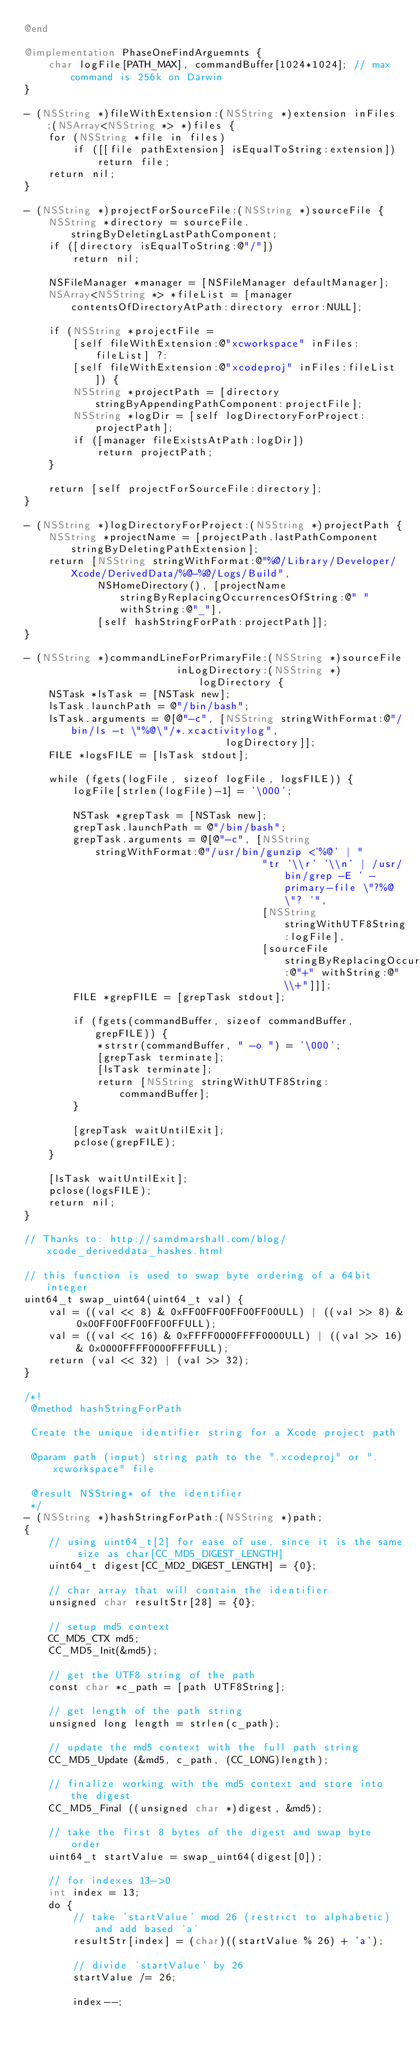Convert code to text. <code><loc_0><loc_0><loc_500><loc_500><_ObjectiveC_>@end

@implementation PhaseOneFindArguemnts {
    char logFile[PATH_MAX], commandBuffer[1024*1024]; // max command is 256k on Darwin
}

- (NSString *)fileWithExtension:(NSString *)extension inFiles:(NSArray<NSString *> *)files {
    for (NSString *file in files)
        if ([[file pathExtension] isEqualToString:extension])
            return file;
    return nil;
}

- (NSString *)projectForSourceFile:(NSString *)sourceFile {
    NSString *directory = sourceFile.stringByDeletingLastPathComponent;
    if ([directory isEqualToString:@"/"])
        return nil;

    NSFileManager *manager = [NSFileManager defaultManager];
    NSArray<NSString *> *fileList = [manager contentsOfDirectoryAtPath:directory error:NULL];

    if (NSString *projectFile =
        [self fileWithExtension:@"xcworkspace" inFiles:fileList] ?:
        [self fileWithExtension:@"xcodeproj" inFiles:fileList]) {
        NSString *projectPath = [directory stringByAppendingPathComponent:projectFile];
        NSString *logDir = [self logDirectoryForProject:projectPath];
        if ([manager fileExistsAtPath:logDir])
            return projectPath;
    }

    return [self projectForSourceFile:directory];
}

- (NSString *)logDirectoryForProject:(NSString *)projectPath {
    NSString *projectName = [projectPath.lastPathComponent stringByDeletingPathExtension];
    return [NSString stringWithFormat:@"%@/Library/Developer/Xcode/DerivedData/%@-%@/Logs/Build",
            NSHomeDirectory(), [projectName stringByReplacingOccurrencesOfString:@" " withString:@"_"],
            [self hashStringForPath:projectPath]];
}

- (NSString *)commandLineForPrimaryFile:(NSString *)sourceFile
                         inLogDirectory:(NSString *)logDirectory {
    NSTask *lsTask = [NSTask new];
    lsTask.launchPath = @"/bin/bash";
    lsTask.arguments = @[@"-c", [NSString stringWithFormat:@"/bin/ls -t \"%@\"/*.xcactivitylog",
                                 logDirectory]];
    FILE *logsFILE = [lsTask stdout];

    while (fgets(logFile, sizeof logFile, logsFILE)) {
        logFile[strlen(logFile)-1] = '\000';

        NSTask *grepTask = [NSTask new];
        grepTask.launchPath = @"/bin/bash";
        grepTask.arguments = @[@"-c", [NSString stringWithFormat:@"/usr/bin/gunzip <'%@' | "
                                       "tr '\\r' '\\n' | /usr/bin/grep -E ' -primary-file \"?%@\"? '",
                                       [NSString stringWithUTF8String:logFile],
                                       [sourceFile stringByReplacingOccurrencesOfString:@"+" withString:@"\\+"]]];
        FILE *grepFILE = [grepTask stdout];

        if (fgets(commandBuffer, sizeof commandBuffer, grepFILE)) {
            *strstr(commandBuffer, " -o ") = '\000';
            [grepTask terminate];
            [lsTask terminate];
            return [NSString stringWithUTF8String:commandBuffer];
        }

        [grepTask waitUntilExit];
        pclose(grepFILE);
    }

    [lsTask waitUntilExit];
    pclose(logsFILE);
    return nil;
}

// Thanks to: http://samdmarshall.com/blog/xcode_deriveddata_hashes.html

// this function is used to swap byte ordering of a 64bit integer
uint64_t swap_uint64(uint64_t val) {
    val = ((val << 8) & 0xFF00FF00FF00FF00ULL) | ((val >> 8) & 0x00FF00FF00FF00FFULL);
    val = ((val << 16) & 0xFFFF0000FFFF0000ULL) | ((val >> 16) & 0x0000FFFF0000FFFFULL);
    return (val << 32) | (val >> 32);
}

/*!
 @method hashStringForPath

 Create the unique identifier string for a Xcode project path

 @param path (input) string path to the ".xcodeproj" or ".xcworkspace" file

 @result NSString* of the identifier
 */
- (NSString *)hashStringForPath:(NSString *)path;
{
    // using uint64_t[2] for ease of use, since it is the same size as char[CC_MD5_DIGEST_LENGTH]
    uint64_t digest[CC_MD2_DIGEST_LENGTH] = {0};

    // char array that will contain the identifier
    unsigned char resultStr[28] = {0};

    // setup md5 context
    CC_MD5_CTX md5;
    CC_MD5_Init(&md5);

    // get the UTF8 string of the path
    const char *c_path = [path UTF8String];

    // get length of the path string
    unsigned long length = strlen(c_path);

    // update the md5 context with the full path string
    CC_MD5_Update (&md5, c_path, (CC_LONG)length);

    // finalize working with the md5 context and store into the digest
    CC_MD5_Final ((unsigned char *)digest, &md5);

    // take the first 8 bytes of the digest and swap byte order
    uint64_t startValue = swap_uint64(digest[0]);

    // for indexes 13->0
    int index = 13;
    do {
        // take 'startValue' mod 26 (restrict to alphabetic) and add based 'a'
        resultStr[index] = (char)((startValue % 26) + 'a');

        // divide 'startValue' by 26
        startValue /= 26;

        index--;</code> 